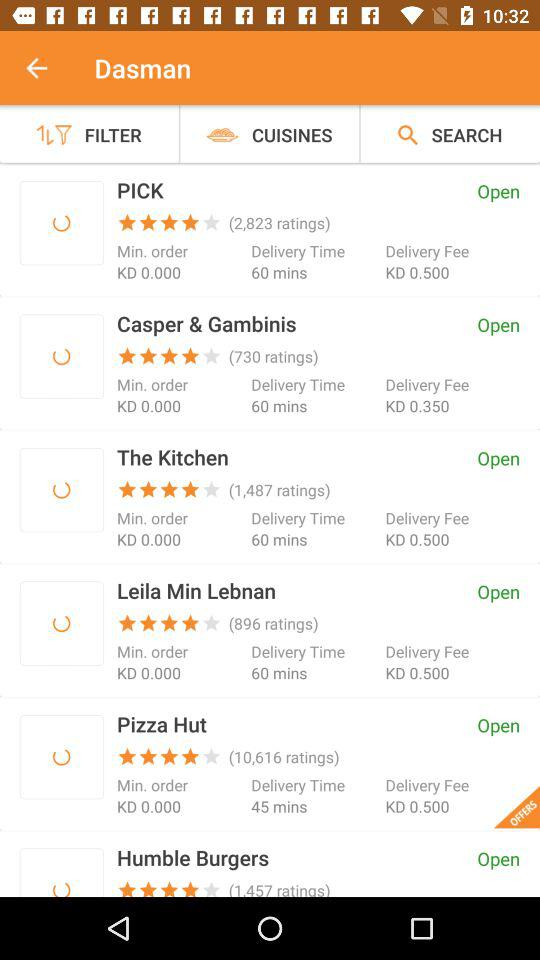Which stores have available offers? The store where offers are available is "Pizza Hut". 